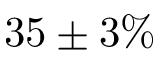<formula> <loc_0><loc_0><loc_500><loc_500>3 5 \pm 3 \%</formula> 